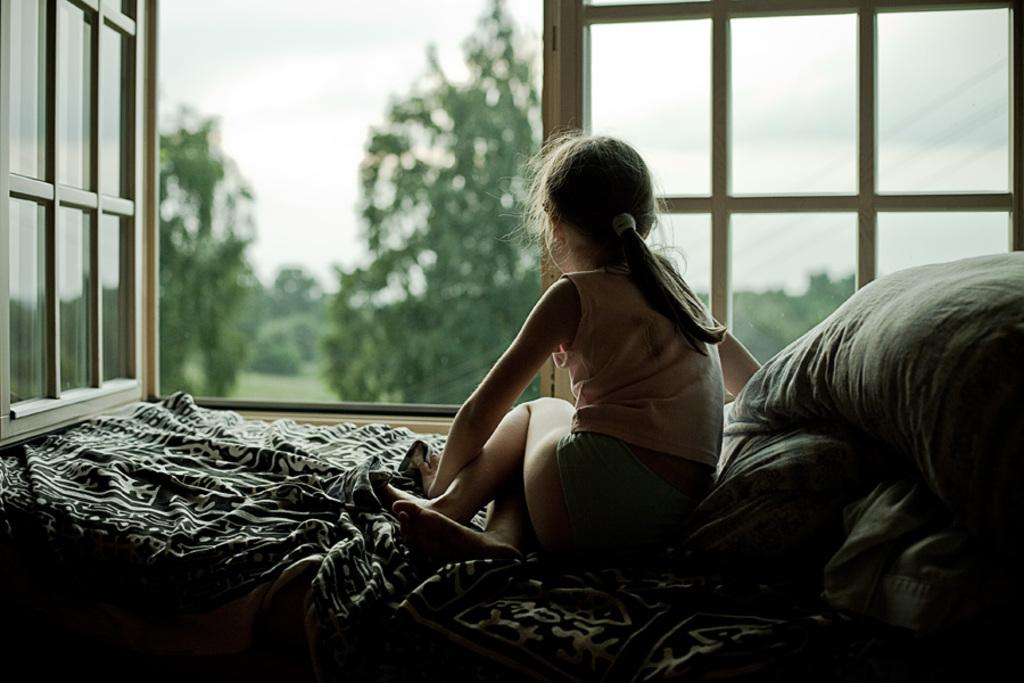What is the girl doing in the image? The girl is sitting on the bed. What is covering the bed? The bed has a blanket. What else is on the bed? There are pillows on the bed. What can be seen in the background of the image? There is a window in the background, and trees on the grassland and the sky are visible through the window. What is the girl's name in the image? The provided facts do not mention the girl's name, so it cannot be determined from the image. 